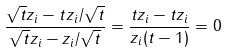Convert formula to latex. <formula><loc_0><loc_0><loc_500><loc_500>\frac { \sqrt { t } z _ { i } - t z _ { i } / \sqrt { t } } { \sqrt { t } z _ { i } - z _ { i } / \sqrt { t } } = \frac { t z _ { i } - t z _ { i } } { z _ { i } ( t - 1 ) } = 0</formula> 